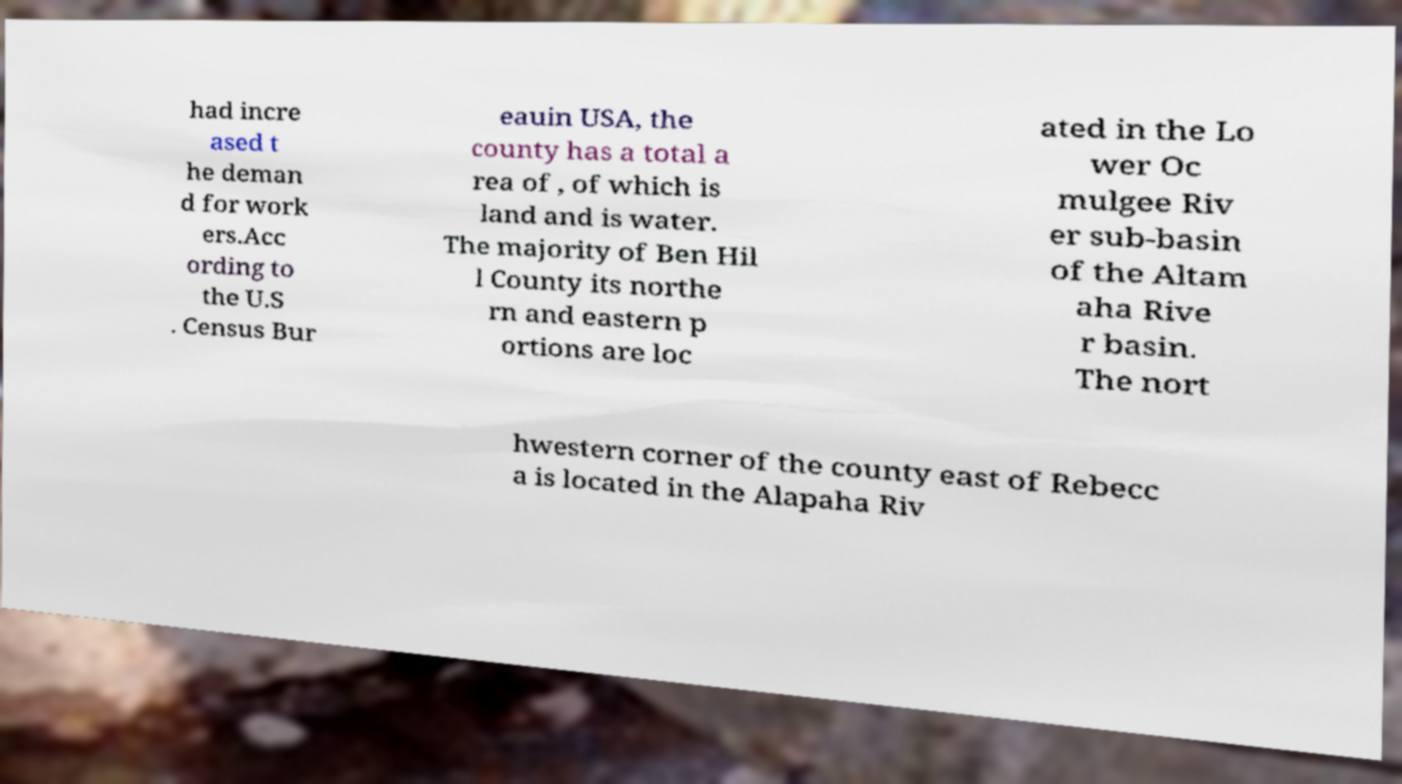I need the written content from this picture converted into text. Can you do that? had incre ased t he deman d for work ers.Acc ording to the U.S . Census Bur eauin USA, the county has a total a rea of , of which is land and is water. The majority of Ben Hil l County its northe rn and eastern p ortions are loc ated in the Lo wer Oc mulgee Riv er sub-basin of the Altam aha Rive r basin. The nort hwestern corner of the county east of Rebecc a is located in the Alapaha Riv 